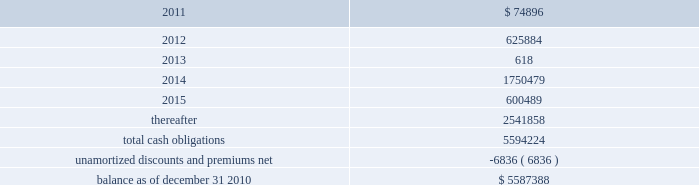American tower corporation and subsidiaries notes to consolidated financial statements as of december 31 , 2010 and 2009 , the company had $ 295.4 million and $ 295.0 million net , respectively ( $ 300.0 million aggregate principal amount ) outstanding under the 7.25% ( 7.25 % ) notes .
As of december 31 , 2010 and 2009 , the carrying value includes a discount of $ 4.6 million and $ 5.0 million , respectively .
5.0% ( 5.0 % ) convertible notes 2014the 5.0% ( 5.0 % ) convertible notes due 2010 ( 201c5.0% ( 201c5.0 % ) notes 201d ) matured on february 15 , 2010 , and interest was payable semiannually on february 15 and august 15 of each year .
The 5.0% ( 5.0 % ) notes were convertible at any time into shares of the company 2019s class a common stock ( 201ccommon stock 201d ) at a conversion price of $ 51.50 per share , subject to adjustment in certain cases .
As of december 31 , 2010 and 2009 , the company had none and $ 59.7 million outstanding , respectively , under the 5.0% ( 5.0 % ) notes .
Ati 7.25% ( 7.25 % ) senior subordinated notes 2014the ati 7.25% ( 7.25 % ) notes were issued with a maturity of december 1 , 2011 and interest was payable semi-annually in arrears on june 1 and december 1 of each year .
The ati 7.25% ( 7.25 % ) notes were jointly and severally guaranteed on a senior subordinated basis by the company and substantially all of the wholly owned domestic restricted subsidiaries of ati and the company , other than spectrasite and its subsidiaries .
The notes ranked junior in right of payment to all existing and future senior indebtedness of ati , the sister guarantors ( as defined in the indenture relating to the notes ) and their domestic restricted subsidiaries .
The ati 7.25% ( 7.25 % ) notes were structurally senior in right of payment to all other existing and future indebtedness of the company , including the company 2019s senior notes , convertible notes and the revolving credit facility and term loan .
During the year ended december 31 , 2010 , ati issued a notice for the redemption of the principal amount of its outstanding ati 7.25% ( 7.25 % ) notes .
In accordance with the redemption provisions and the indenture for the ati 7.25% ( 7.25 % ) notes , the notes were redeemed at a price equal to 100.00% ( 100.00 % ) of the principal amount , plus accrued and unpaid interest up to , but excluding , september 23 , 2010 , for an aggregate purchase price of $ 0.3 million .
As of december 31 , 2010 and 2009 , the company had none and $ 0.3 million , respectively , outstanding under the ati 7.25% ( 7.25 % ) notes .
Capital lease obligations and notes payable 2014the company 2019s capital lease obligations and notes payable approximated $ 46.3 million and $ 59.0 million as of december 31 , 2010 and 2009 , respectively .
These obligations bear interest at rates ranging from 2.5% ( 2.5 % ) to 9.3% ( 9.3 % ) and mature in periods ranging from less than one year to approximately seventy years .
Maturities 2014as of december 31 , 2010 , aggregate carrying value of long-term debt , including capital leases , for the next five years and thereafter are estimated to be ( in thousands ) : year ending december 31 .

What portion of total cash obligations is due within the next 12 months? 
Computations: (74896 / 5594224)
Answer: 0.01339. 